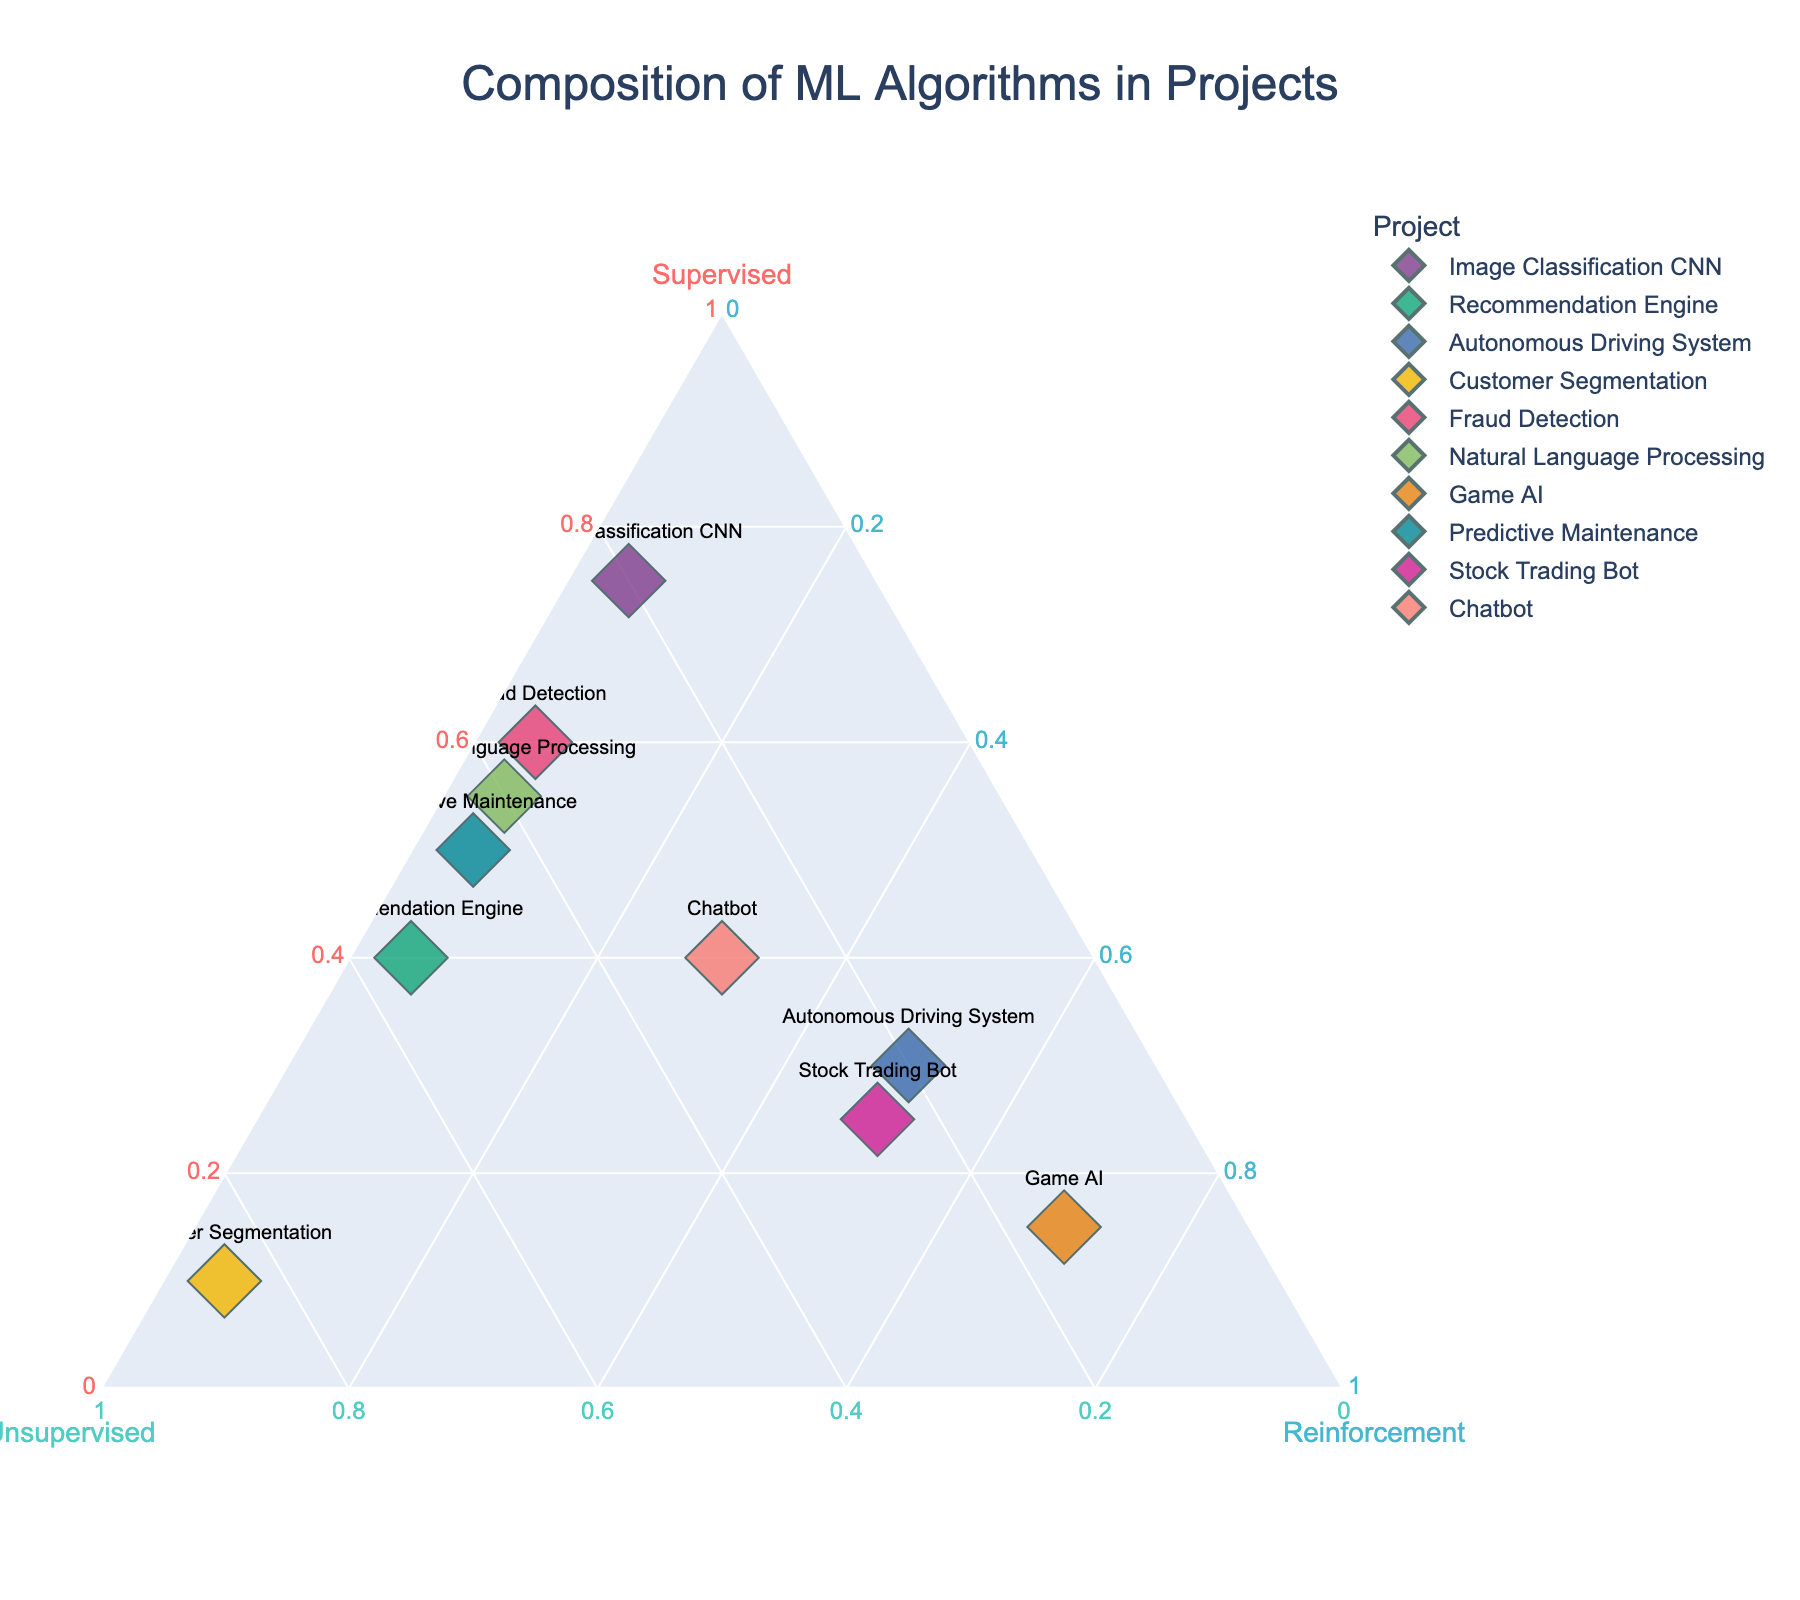What is the title of the plot? The title of the plot is displayed at the top of the figure.
Answer: Composition of ML Algorithms in Projects How many data points are plotted in the figure? Count the number of points in the figure. Each data point represents a specific project.
Answer: 10 Which project uses the highest percentage of supervised learning? Identify the data point closest to the apex of the "Supervised" axis.
Answer: Image Classification CNN Which project uses equal amounts of supervised and unsupervised learning? Find data points that lie on the line equidistant from the "Supervised" and "Unsupervised" axes.
Answer: Chatbot What is the composition of the Natural Language Processing project in terms of machine learning algorithms? Locate the "Natural Language Processing" data point and read the percentages from the axes.
Answer: Supervised: 55%, Unsupervised: 40%, Reinforcement: 5% Compare the use of reinforcement learning between Game AI and Stock Trading Bot. Which one relies more on reinforcement learning? Look at the positions of "Game AI" and "Stock Trading Bot" data points relative to the "Reinforcement" axis.
Answer: Game AI Which project has the highest reliance on unsupervised learning? Find the data point closest to the apex of the "Unsupervised" axis.
Answer: Customer Segmentation Is there any project that has an equal proportion of all three types of learning? Check if there's any data point equidistant from all three axes.
Answer: No Which projects have a reinforcement learning proportion of 50%? Identify the points lying on the halfway mark of the "Reinforcement" axis.
Answer: Autonomous Driving System, Stock Trading Bot 